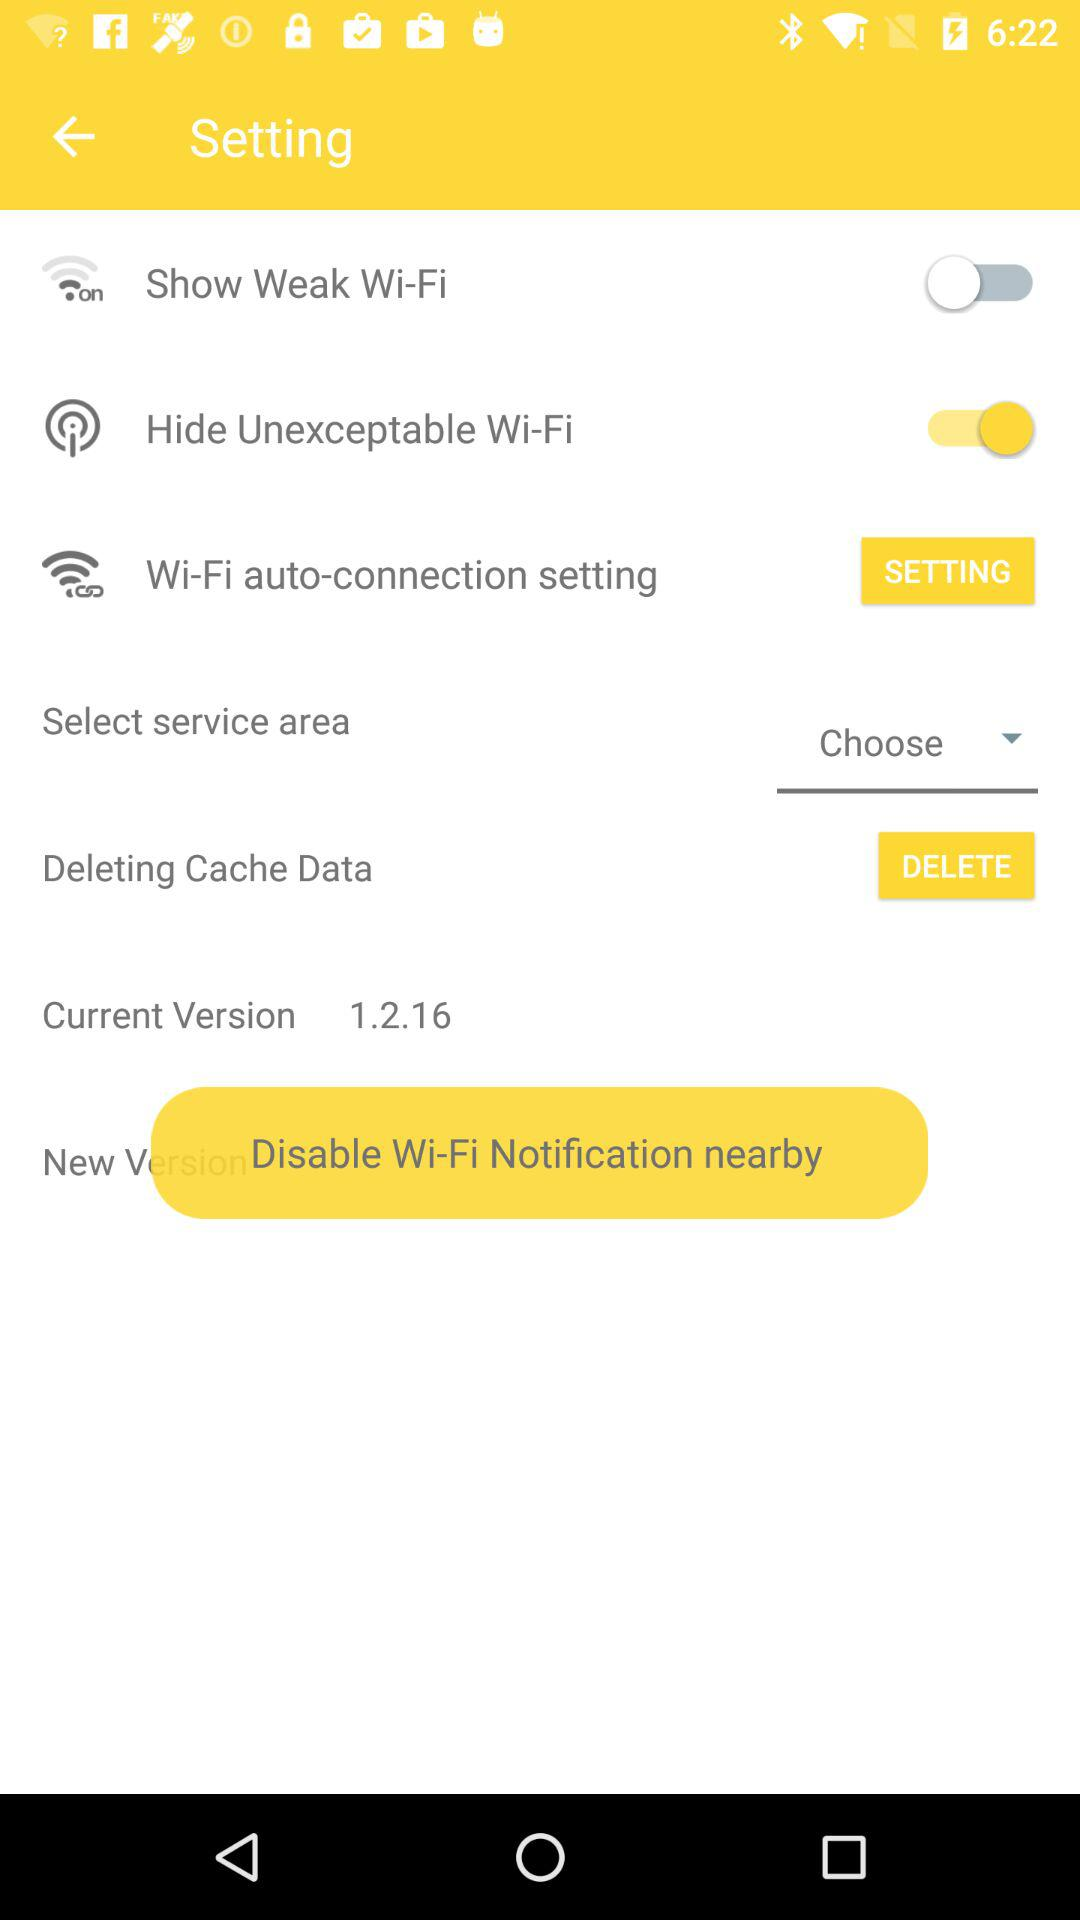Which service area is chosen?
When the provided information is insufficient, respond with <no answer>. <no answer> 